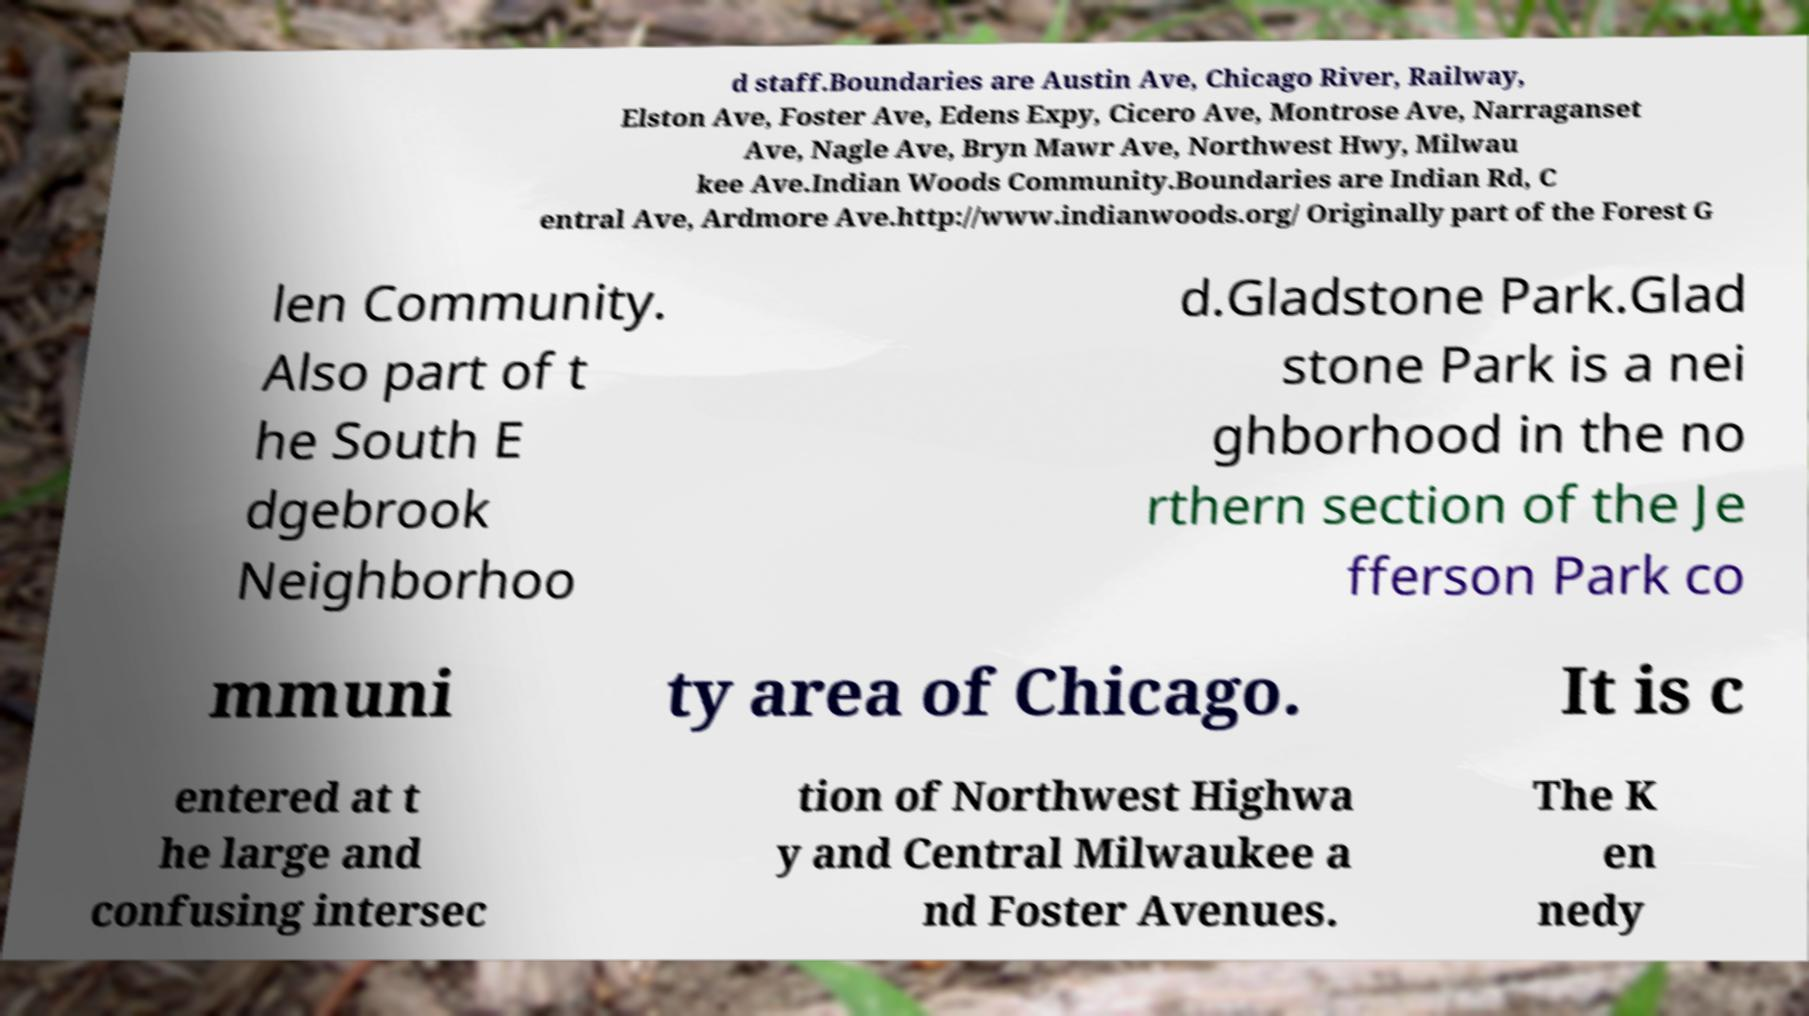Please identify and transcribe the text found in this image. d staff.Boundaries are Austin Ave, Chicago River, Railway, Elston Ave, Foster Ave, Edens Expy, Cicero Ave, Montrose Ave, Narraganset Ave, Nagle Ave, Bryn Mawr Ave, Northwest Hwy, Milwau kee Ave.Indian Woods Community.Boundaries are Indian Rd, C entral Ave, Ardmore Ave.http://www.indianwoods.org/ Originally part of the Forest G len Community. Also part of t he South E dgebrook Neighborhoo d.Gladstone Park.Glad stone Park is a nei ghborhood in the no rthern section of the Je fferson Park co mmuni ty area of Chicago. It is c entered at t he large and confusing intersec tion of Northwest Highwa y and Central Milwaukee a nd Foster Avenues. The K en nedy 